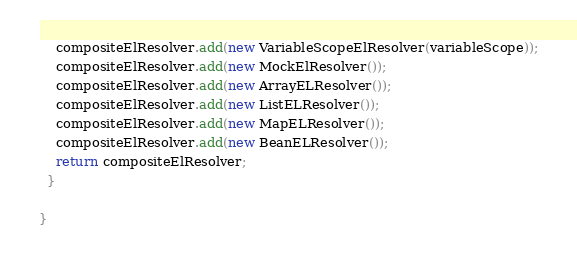<code> <loc_0><loc_0><loc_500><loc_500><_Java_>    compositeElResolver.add(new VariableScopeElResolver(variableScope));
    compositeElResolver.add(new MockElResolver());
    compositeElResolver.add(new ArrayELResolver());
    compositeElResolver.add(new ListELResolver());
    compositeElResolver.add(new MapELResolver());
    compositeElResolver.add(new BeanELResolver());
    return compositeElResolver;
  }

}
</code> 